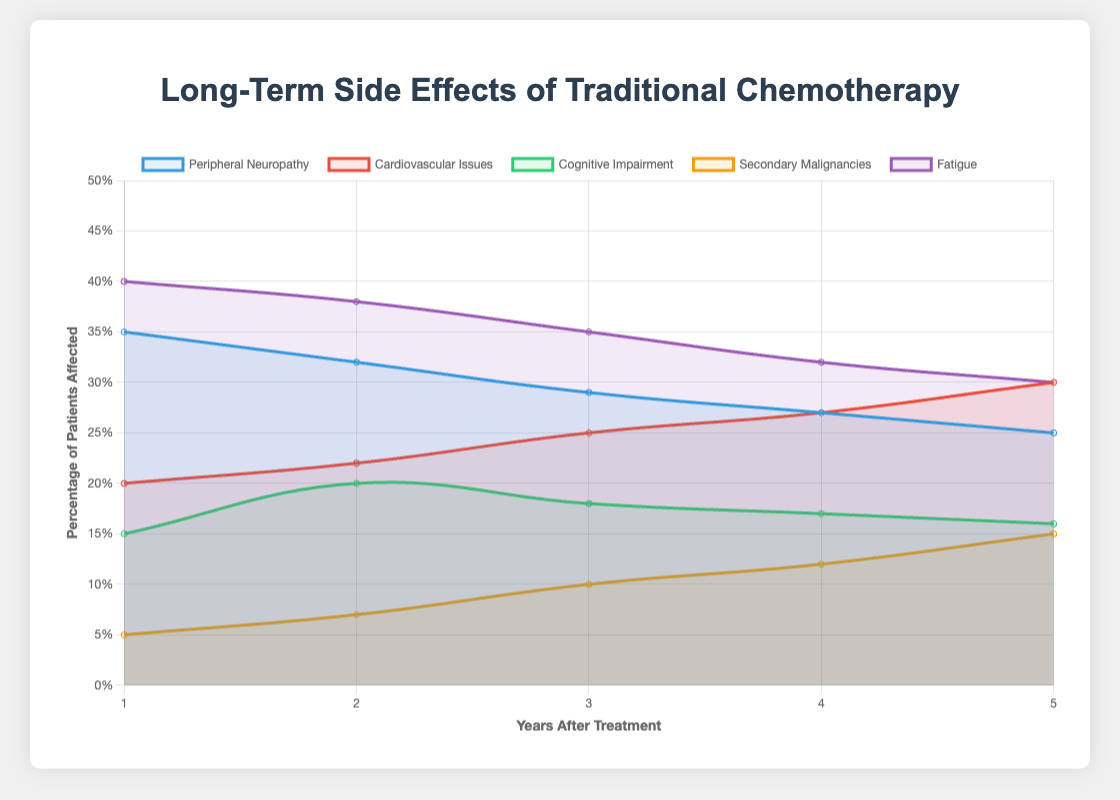What is the percentage change in patients affected by Peripheral Neuropathy from year 1 to year 5? The percentage affected by Peripheral Neuropathy at year 1 is 35%, and at year 5, it is 25%. The percentage change is calculated as [(25 - 35) / 35] * 100 = -28.57%.
Answer: -28.57% Among all side effects at year 3, which has the highest percentage of patients affected? At year 3, the percentages of patients affected by various side effects are: Peripheral Neuropathy (29%), Cardiovascular Issues (25%), Cognitive Impairment (18%), Secondary Malignancies (10%), and Fatigue (35%). Fatigue has the highest percentage of patients affected.
Answer: Fatigue How does the trend of Cognitive Impairment differ visually from the trend of Cardiovascular Issues over 5 years? The Cognitive Impairment percentage rises from year 1 to year 2 (15% to 20%), then decreases slightly from year 3 to year 5 (20% to 18% to 17% to 16%). In contrast, the trend for Cardiovascular Issues shows a consistent increase from year 1 to year 5 (20% to 30%).
Answer: Cognitive Impairment decreases after year 2, whereas Cardiovascular Issues increase consistently What is the range of percentages affected by Secondary Malignancies over 5 years? The percentage of patients affected by Secondary Malignancies goes from 5% in year 1 to 15% in year 5. The range is calculated by subtracting the smallest percentage from the largest: 15% - 5% = 10%.
Answer: 10% If a patient is chosen at random in year 4, which side effect are they most likely to suffer from? In year 4, the percentages of patients affected by different side effects are: Peripheral Neuropathy (27%), Cardiovascular Issues (27%), Cognitive Impairment (17%), Secondary Malignancies (12%), and Fatigue (32%). Fatigue has the highest percentage.
Answer: Fatigue What is the cumulative percentage of patients affected by Cognitive Impairment over 5 years? The percentages for Cognitive Impairment across the five years are 15%, 20%, 18%, 17%, and 16%. The cumulative percentage is the sum of these values: 15 + 20 + 18 + 17 + 16 = 86%.
Answer: 86% Which side effect shows the least variability in percentages over 5 years? The side effect with the percentages fluctuating the least over 5 years would have the smallest difference between its maximum and minimum values. By comparing Peripheral Neuropathy (35%-25%=10), Cardiovascular Issues (30%-20%=10), Cognitive Impairment (20%-15%=5), Secondary Malignancies (15%-5%=10), and Fatigue (40%-30%=10), Cognitive Impairment shows the least variability.
Answer: Cognitive Impairment What is the average annual percentage of patients affected by Fatigue over the 5-year period? The percentages of patients affected by Fatigue are 40%, 38%, 35%, 32%, and 30% over the five years. The average is calculated by summing these percentages and then dividing by 5: (40 + 38 + 35 + 32 + 30) / 5 = 35%.
Answer: 35% What side effect increases in percentage of patients affected every year? The only side effect that shows an increase in percentage every consecutive year is Secondary Malignancies, with percentages 5%, 7%, 10%, 12%, 15% from year 1 to year 5.
Answer: Secondary Malignancies What is the difference in percentage of patients affected by Peripheral Neuropathy and Cardiovascular Issues at year 2? At year 2, Peripheral Neuropathy affects 32% of patients, while Cardiovascular Issues affect 22%. The difference is 32% - 22% = 10%.
Answer: 10% 